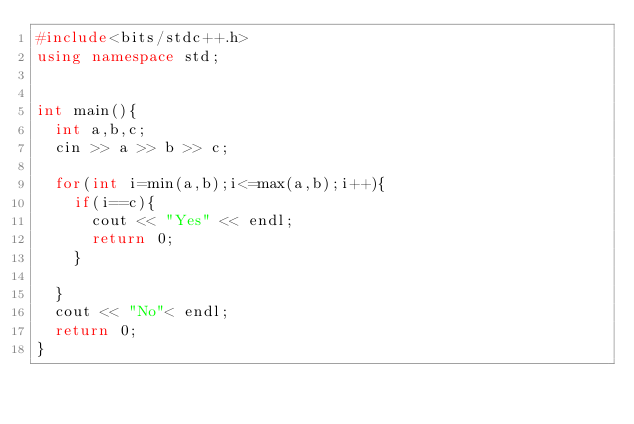<code> <loc_0><loc_0><loc_500><loc_500><_C++_>#include<bits/stdc++.h>
using namespace std;


int main(){
	int a,b,c;
	cin >> a >> b >> c;
	
	for(int i=min(a,b);i<=max(a,b);i++){
		if(i==c){
			cout << "Yes" << endl;
			return 0;
		}
		
	}
	cout << "No"< endl;
	return 0;
}</code> 